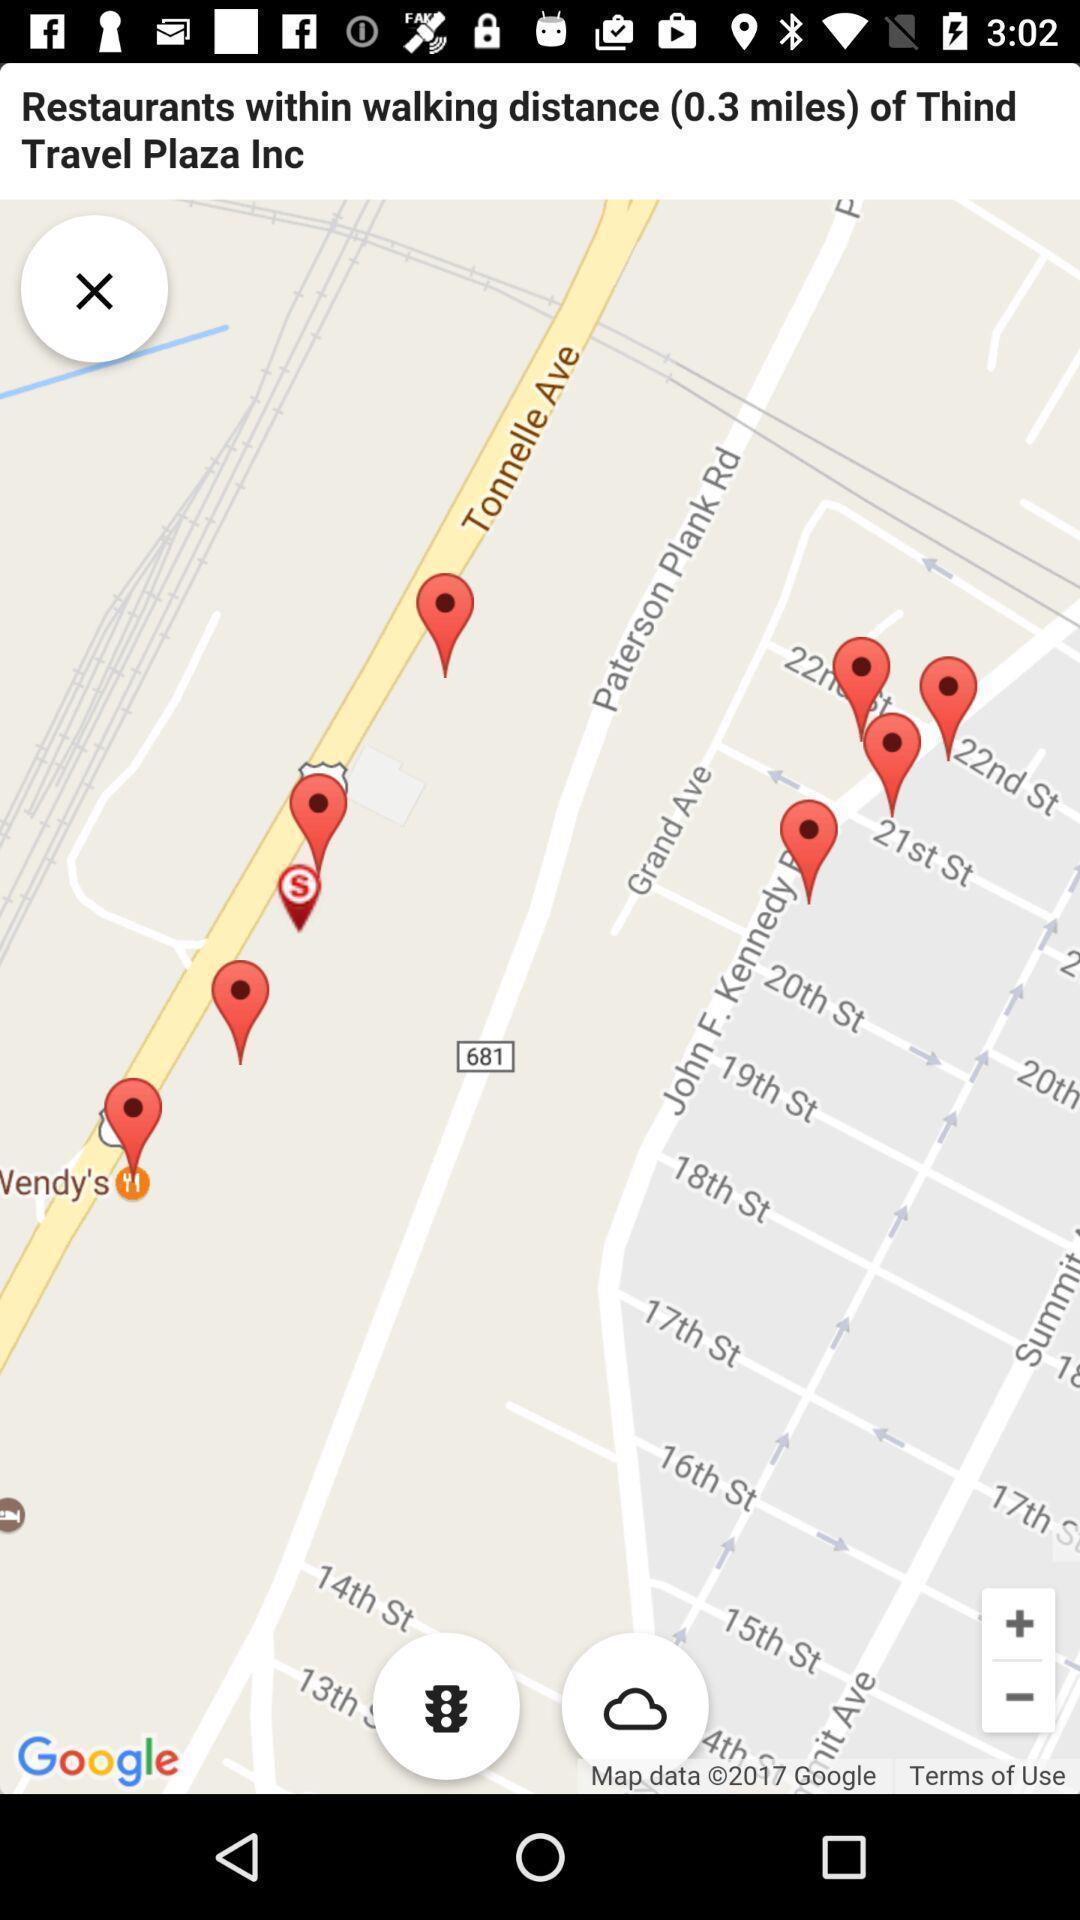What can you discern from this picture? Page displaying the location to restaurants. 